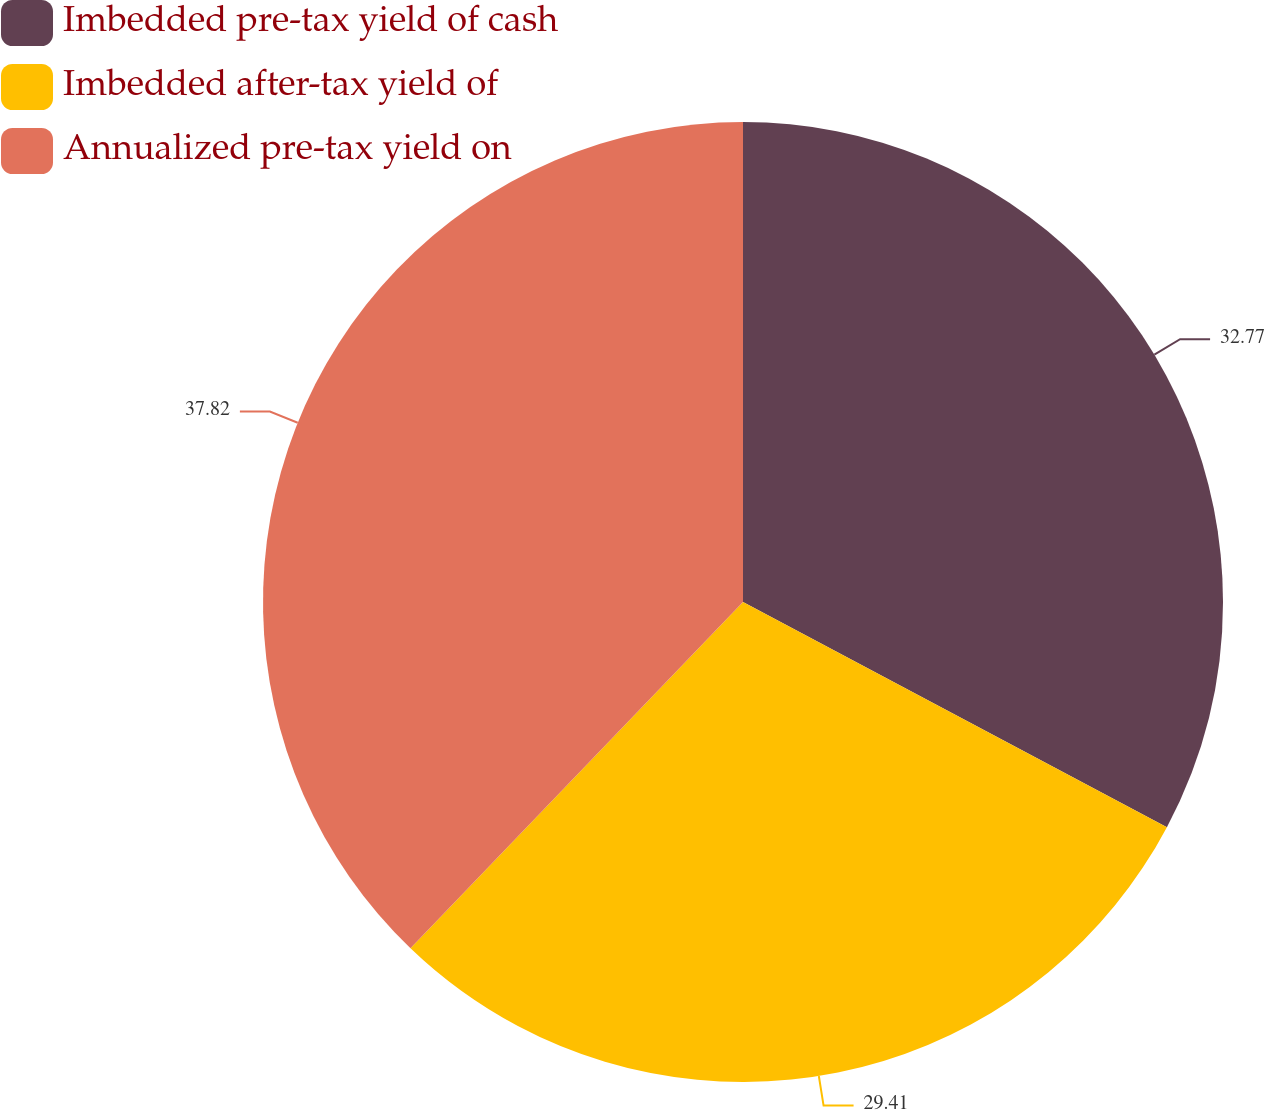Convert chart to OTSL. <chart><loc_0><loc_0><loc_500><loc_500><pie_chart><fcel>Imbedded pre-tax yield of cash<fcel>Imbedded after-tax yield of<fcel>Annualized pre-tax yield on<nl><fcel>32.77%<fcel>29.41%<fcel>37.82%<nl></chart> 